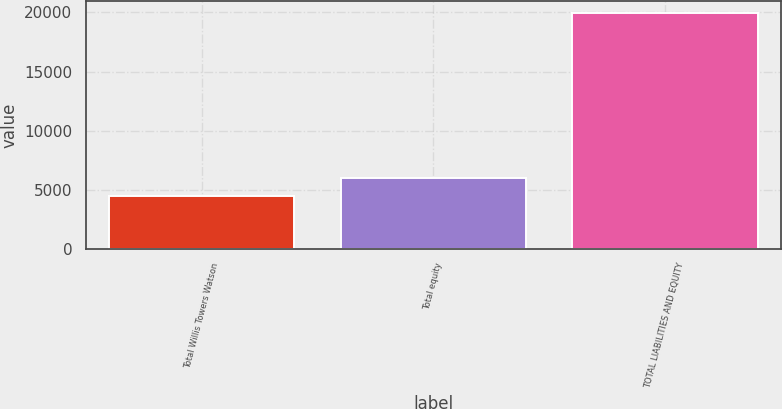<chart> <loc_0><loc_0><loc_500><loc_500><bar_chart><fcel>Total Willis Towers Watson<fcel>Total equity<fcel>TOTAL LIABILITIES AND EQUITY<nl><fcel>4422<fcel>5975.5<fcel>19957<nl></chart> 